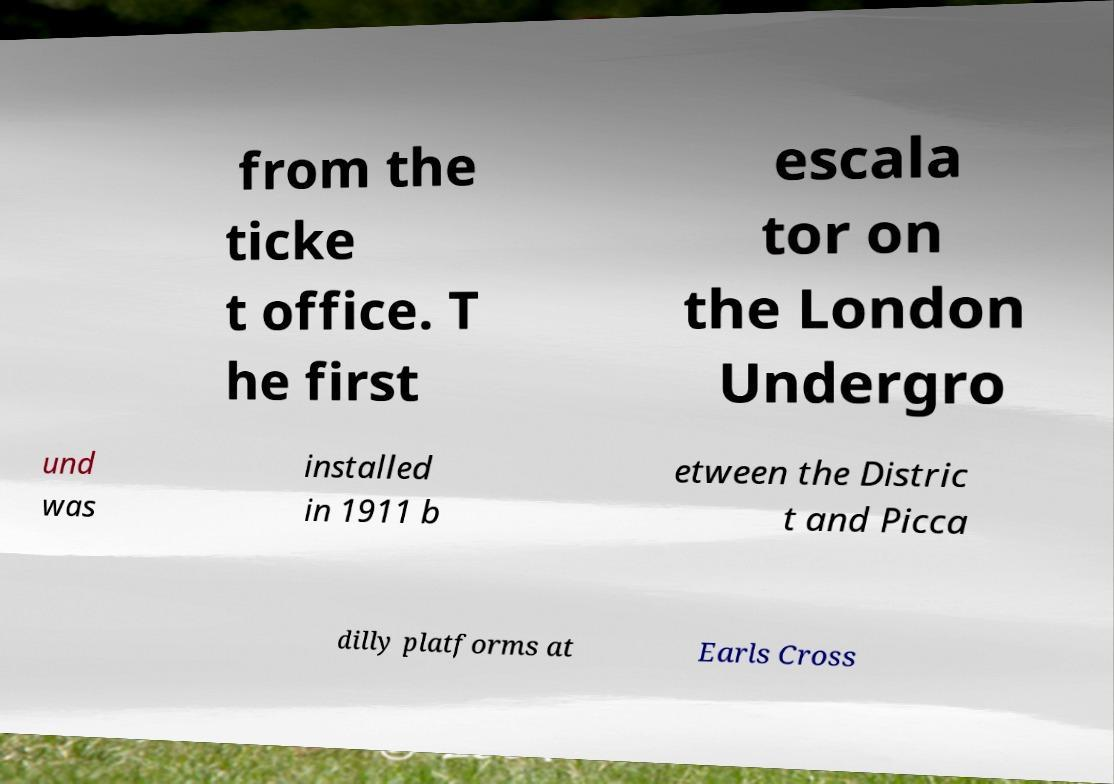I need the written content from this picture converted into text. Can you do that? from the ticke t office. T he first escala tor on the London Undergro und was installed in 1911 b etween the Distric t and Picca dilly platforms at Earls Cross 